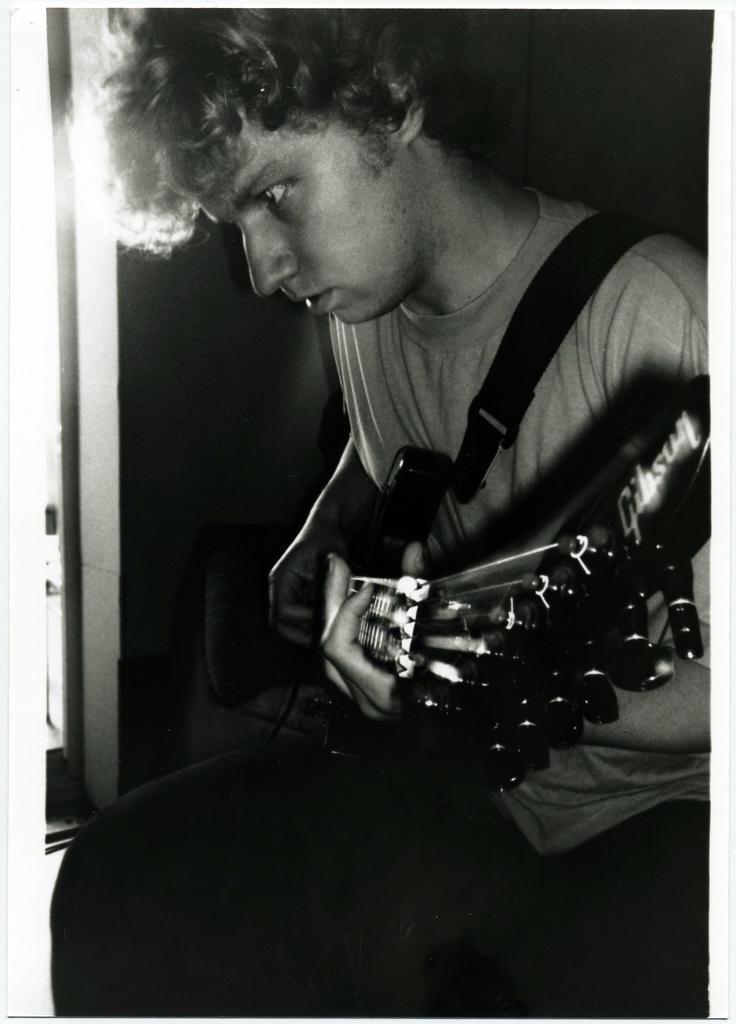Could you give a brief overview of what you see in this image? There is a person in a t-shirt, sitting, holding a guitar and playing. The background is dark in color. 